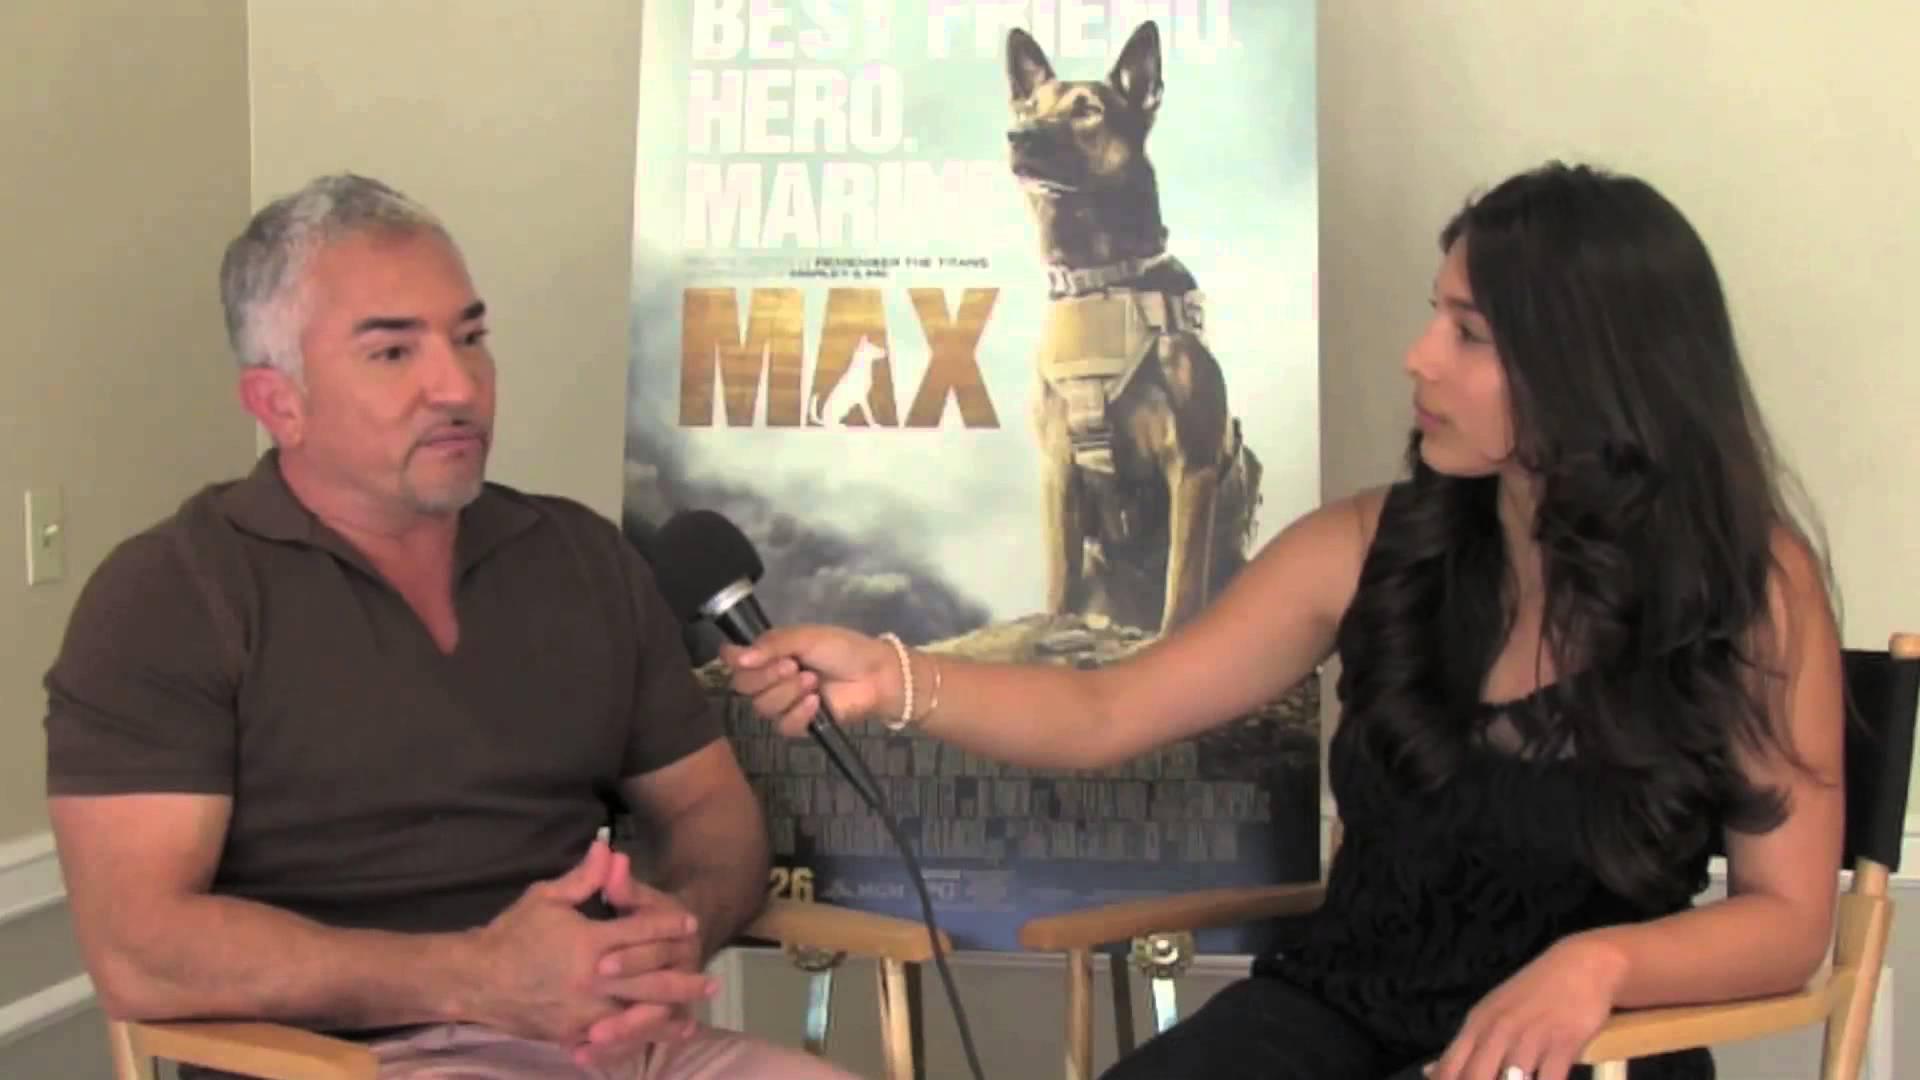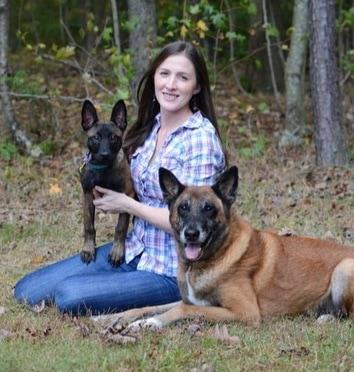The first image is the image on the left, the second image is the image on the right. For the images displayed, is the sentence "At least one person appears in each image." factually correct? Answer yes or no. Yes. 